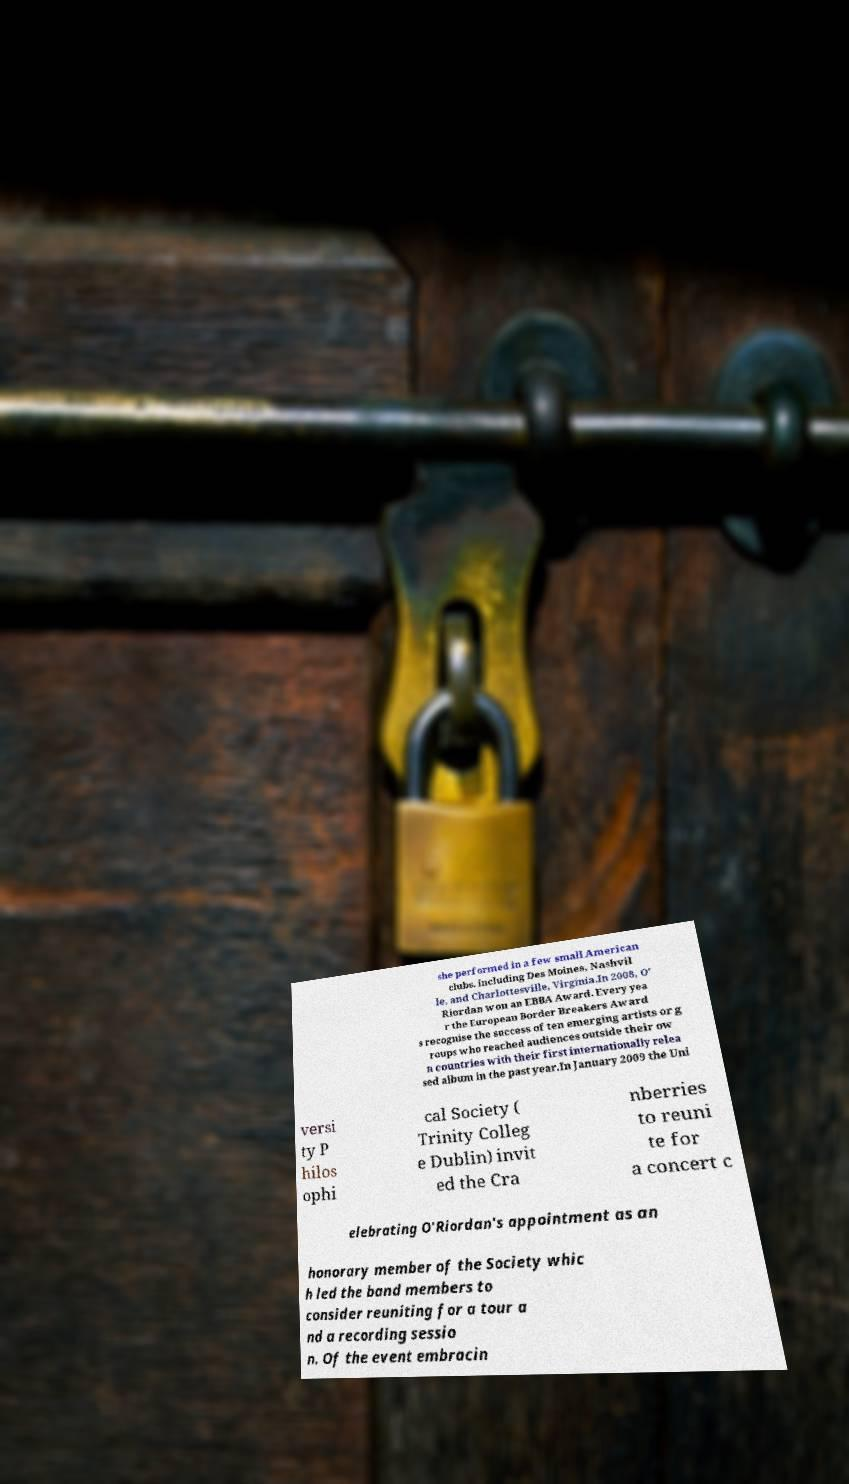Could you assist in decoding the text presented in this image and type it out clearly? she performed in a few small American clubs, including Des Moines, Nashvil le, and Charlottesville, Virginia.In 2008, O' Riordan won an EBBA Award. Every yea r the European Border Breakers Award s recognise the success of ten emerging artists or g roups who reached audiences outside their ow n countries with their first internationally relea sed album in the past year.In January 2009 the Uni versi ty P hilos ophi cal Society ( Trinity Colleg e Dublin) invit ed the Cra nberries to reuni te for a concert c elebrating O'Riordan's appointment as an honorary member of the Society whic h led the band members to consider reuniting for a tour a nd a recording sessio n. Of the event embracin 